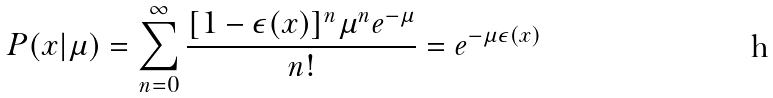<formula> <loc_0><loc_0><loc_500><loc_500>P ( x | \mu ) = \sum _ { n = 0 } ^ { \infty } \frac { [ 1 - \epsilon ( x ) ] ^ { n } \mu ^ { n } e ^ { - \mu } } { n ! } = e ^ { - \mu \epsilon ( x ) }</formula> 